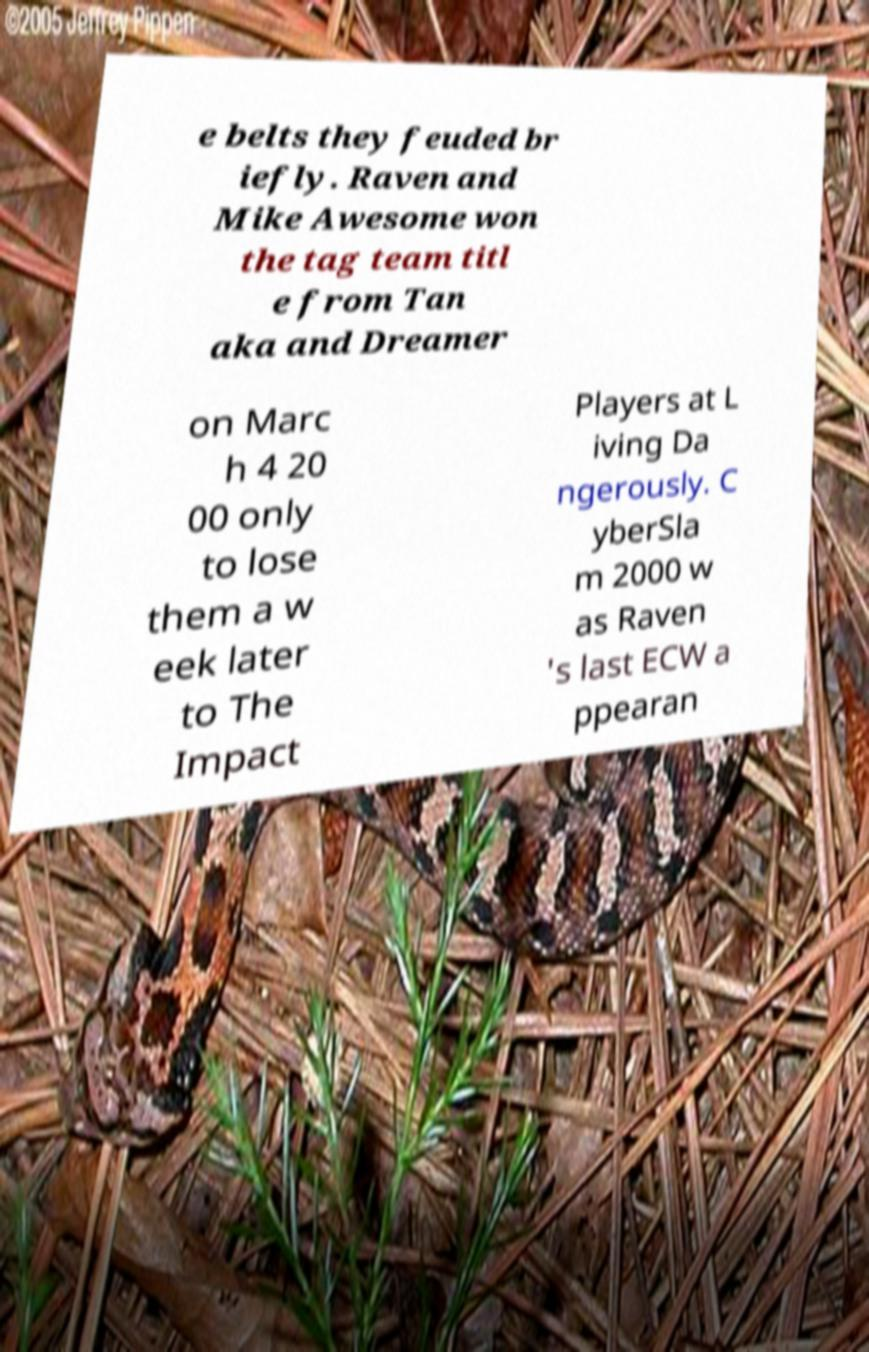Can you accurately transcribe the text from the provided image for me? e belts they feuded br iefly. Raven and Mike Awesome won the tag team titl e from Tan aka and Dreamer on Marc h 4 20 00 only to lose them a w eek later to The Impact Players at L iving Da ngerously. C yberSla m 2000 w as Raven 's last ECW a ppearan 